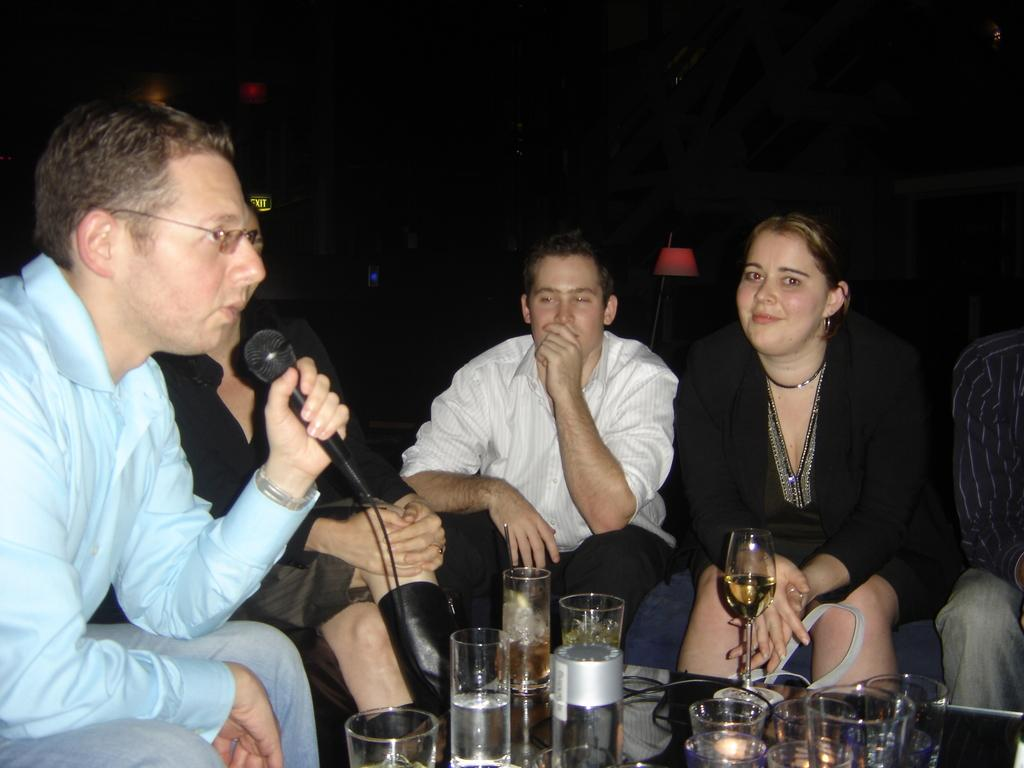What is the man doing on the left side of the image? The man is sitting on the left side of the image. What is the man wearing? The man is wearing a shirt. What object is the man holding? The man is holding a microphone. What is the woman doing on the right side of the image? The woman is sitting on the right side of the image. What objects can be seen near the people in the image? There are wine glasses visible in the image. What type of quartz is visible in the middle of the image? There is no quartz present in the image. What event is taking place in the image? The image does not provide enough information to determine if an event is taking place. 